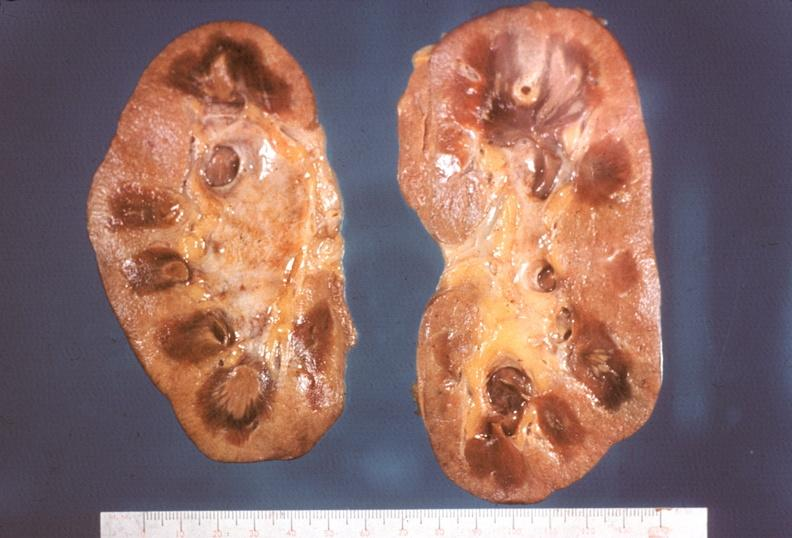does lupus erythematosus periarterial fibrosis show kidney, papillitis, necrotizing?
Answer the question using a single word or phrase. No 